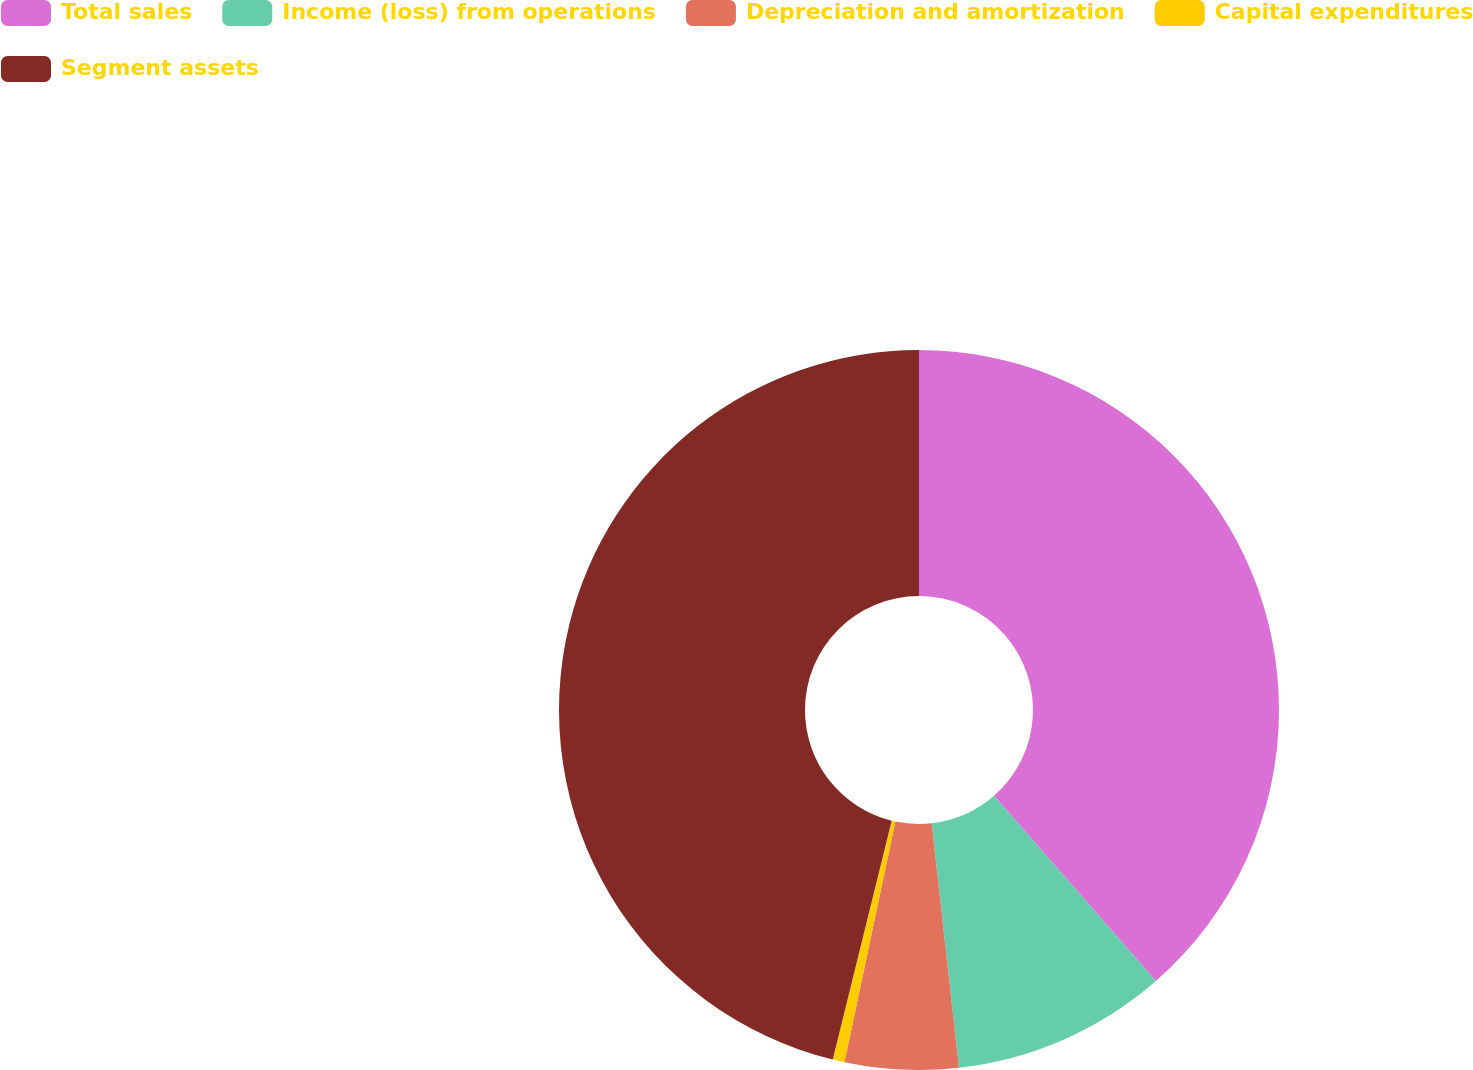Convert chart to OTSL. <chart><loc_0><loc_0><loc_500><loc_500><pie_chart><fcel>Total sales<fcel>Income (loss) from operations<fcel>Depreciation and amortization<fcel>Capital expenditures<fcel>Segment assets<nl><fcel>38.57%<fcel>9.66%<fcel>5.09%<fcel>0.53%<fcel>46.15%<nl></chart> 